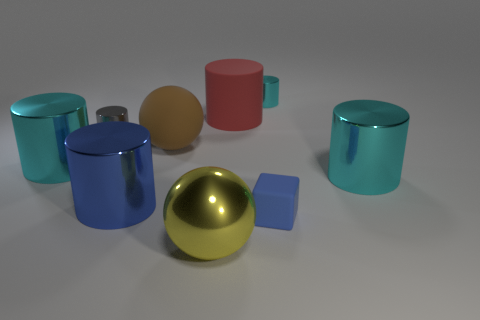Subtract all red balls. How many cyan cylinders are left? 3 Subtract all blue metallic cylinders. How many cylinders are left? 5 Add 1 large blue metallic cylinders. How many objects exist? 10 Subtract all gray cylinders. How many cylinders are left? 5 Subtract all blocks. How many objects are left? 8 Subtract all cyan cylinders. Subtract all big balls. How many objects are left? 4 Add 3 blue shiny cylinders. How many blue shiny cylinders are left? 4 Add 4 big brown matte spheres. How many big brown matte spheres exist? 5 Subtract 0 purple blocks. How many objects are left? 9 Subtract all green balls. Subtract all yellow cylinders. How many balls are left? 2 